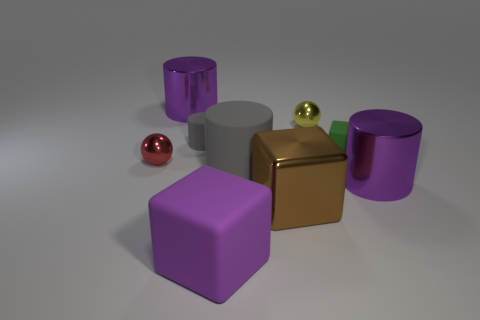Subtract 1 cylinders. How many cylinders are left? 3 Subtract all blocks. How many objects are left? 6 Add 4 balls. How many balls exist? 6 Subtract 1 red spheres. How many objects are left? 8 Subtract all tiny matte things. Subtract all tiny green matte cubes. How many objects are left? 6 Add 7 big purple objects. How many big purple objects are left? 10 